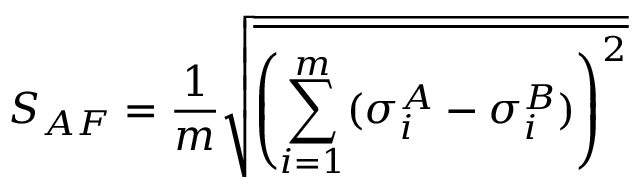<formula> <loc_0><loc_0><loc_500><loc_500>S _ { A F } = \frac { 1 } { m } \sqrt { \overline { { { \left ( \sum _ { i = 1 } ^ { m } ( \sigma _ { i } ^ { A } - \sigma _ { i } ^ { B } ) \right ) } ^ { 2 } } } }</formula> 